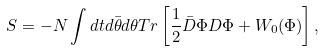Convert formula to latex. <formula><loc_0><loc_0><loc_500><loc_500>S = - N \int d t d \bar { \theta } d \theta T r \left [ \frac { 1 } { 2 } \bar { D } \Phi D \Phi + W _ { 0 } ( \Phi ) \right ] ,</formula> 